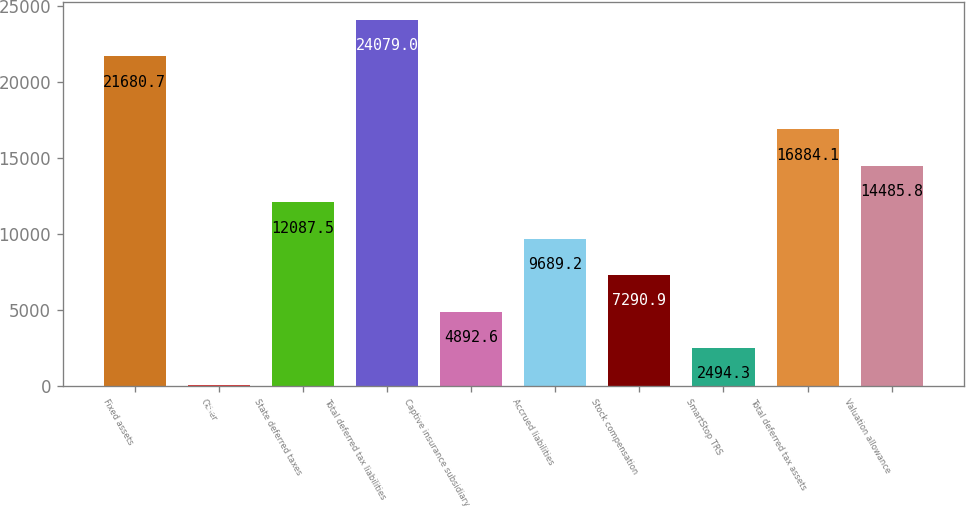<chart> <loc_0><loc_0><loc_500><loc_500><bar_chart><fcel>Fixed assets<fcel>Other<fcel>State deferred taxes<fcel>Total deferred tax liabilities<fcel>Captive insurance subsidiary<fcel>Accrued liabilities<fcel>Stock compensation<fcel>SmartStop TRS<fcel>Total deferred tax assets<fcel>Valuation allowance<nl><fcel>21680.7<fcel>96<fcel>12087.5<fcel>24079<fcel>4892.6<fcel>9689.2<fcel>7290.9<fcel>2494.3<fcel>16884.1<fcel>14485.8<nl></chart> 